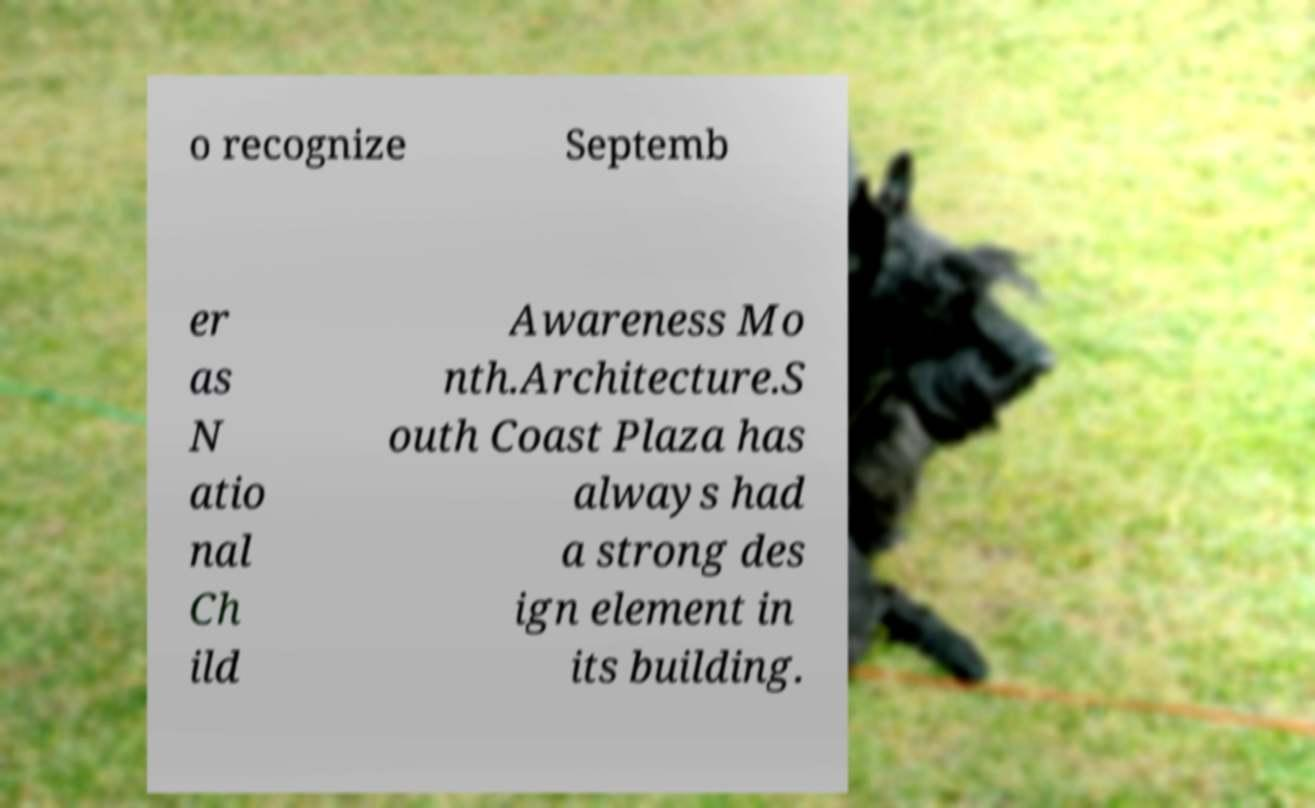For documentation purposes, I need the text within this image transcribed. Could you provide that? o recognize Septemb er as N atio nal Ch ild Awareness Mo nth.Architecture.S outh Coast Plaza has always had a strong des ign element in its building. 